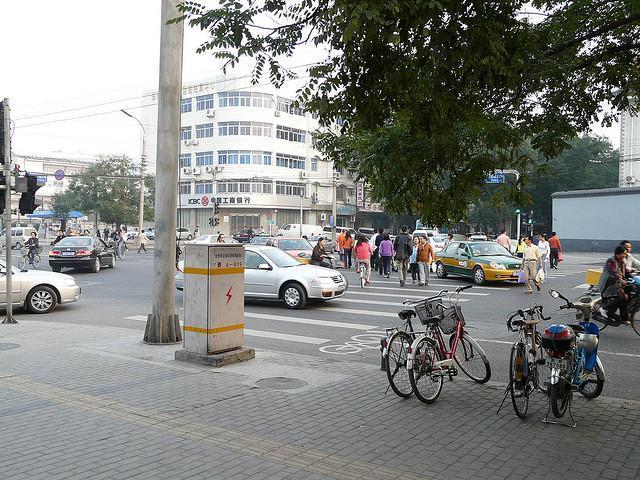How many cars are there?
Give a very brief answer. 4. How many bicycles are there?
Give a very brief answer. 3. How many birds stand on the sand?
Give a very brief answer. 0. 